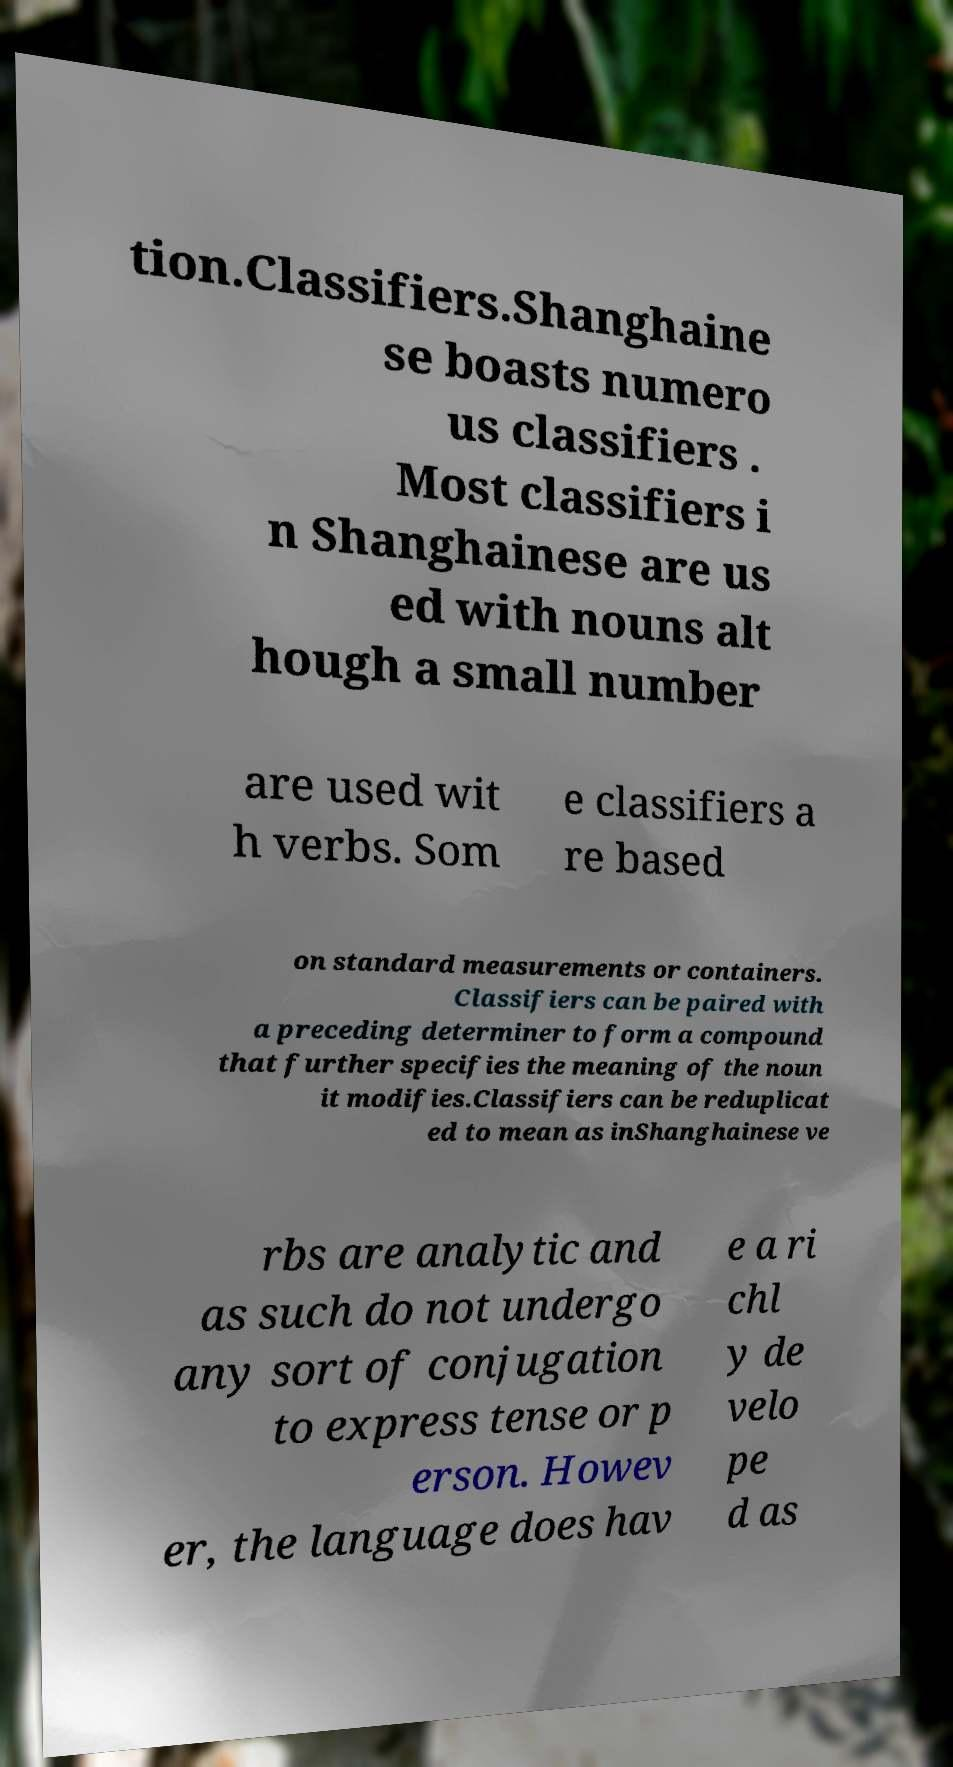There's text embedded in this image that I need extracted. Can you transcribe it verbatim? tion.Classifiers.Shanghaine se boasts numero us classifiers . Most classifiers i n Shanghainese are us ed with nouns alt hough a small number are used wit h verbs. Som e classifiers a re based on standard measurements or containers. Classifiers can be paired with a preceding determiner to form a compound that further specifies the meaning of the noun it modifies.Classifiers can be reduplicat ed to mean as inShanghainese ve rbs are analytic and as such do not undergo any sort of conjugation to express tense or p erson. Howev er, the language does hav e a ri chl y de velo pe d as 